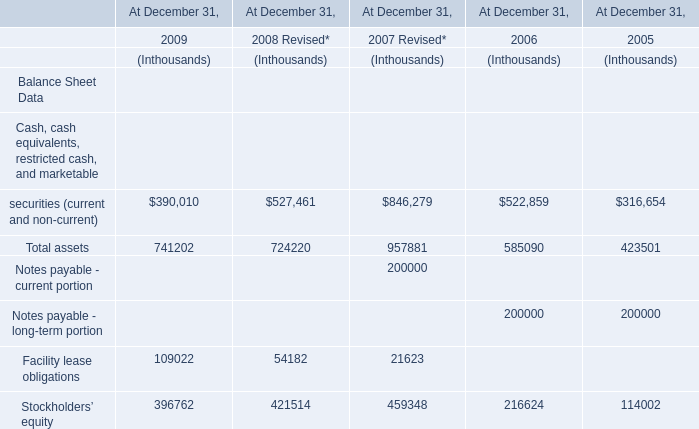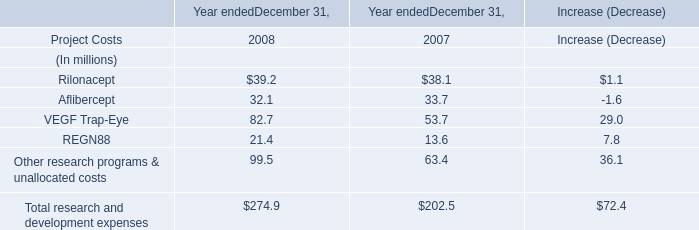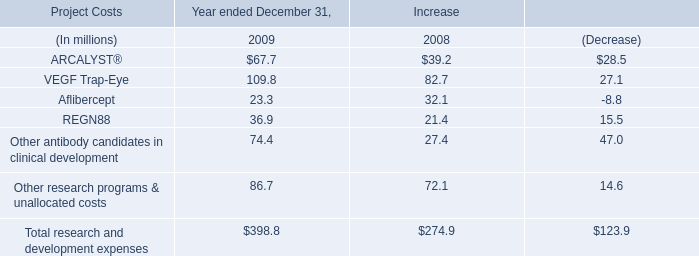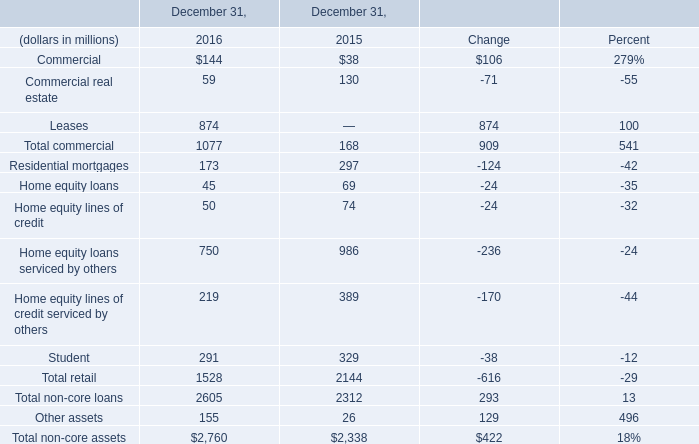Does Commercial keeps increasing each year between 2015 and 2016? 
Answer: yes. 